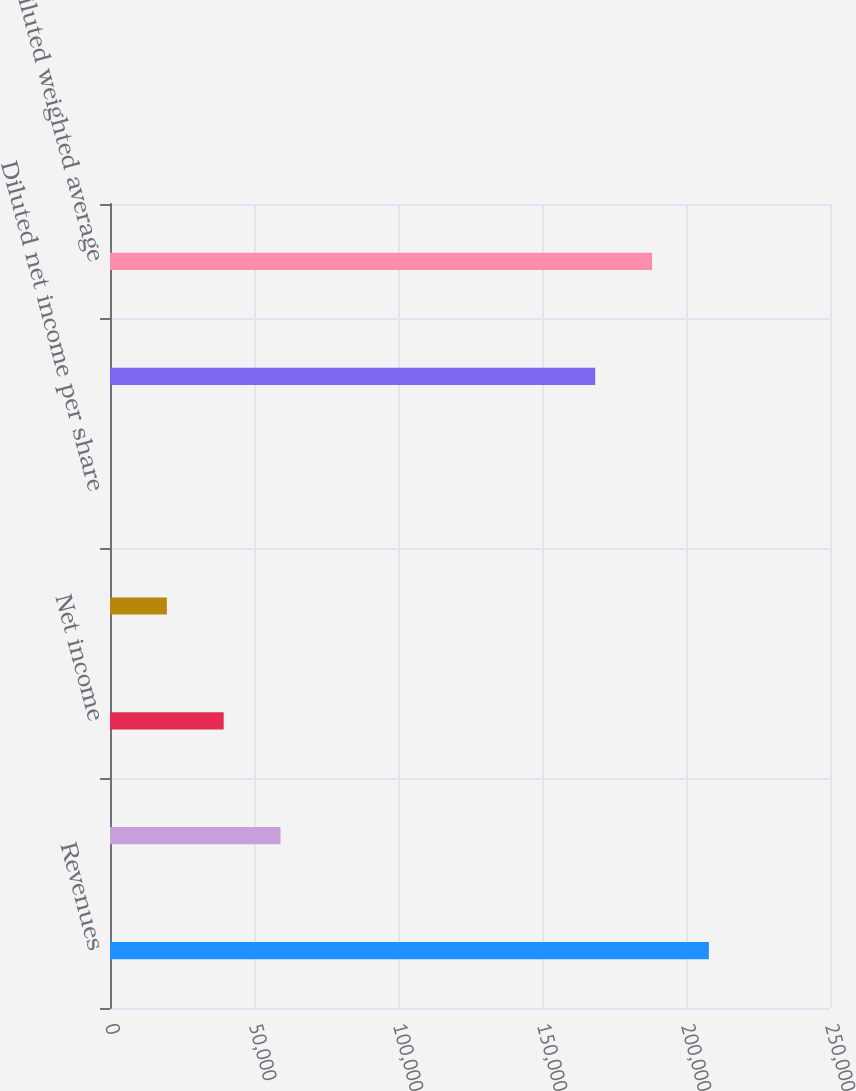<chart> <loc_0><loc_0><loc_500><loc_500><bar_chart><fcel>Revenues<fcel>Cost of revenues<fcel>Net income<fcel>Basic net income per share<fcel>Diluted net income per share<fcel>Basic weighted average common<fcel>Diluted weighted average<nl><fcel>207943<fcel>59204.2<fcel>39469.5<fcel>19734.9<fcel>0.18<fcel>168474<fcel>188209<nl></chart> 